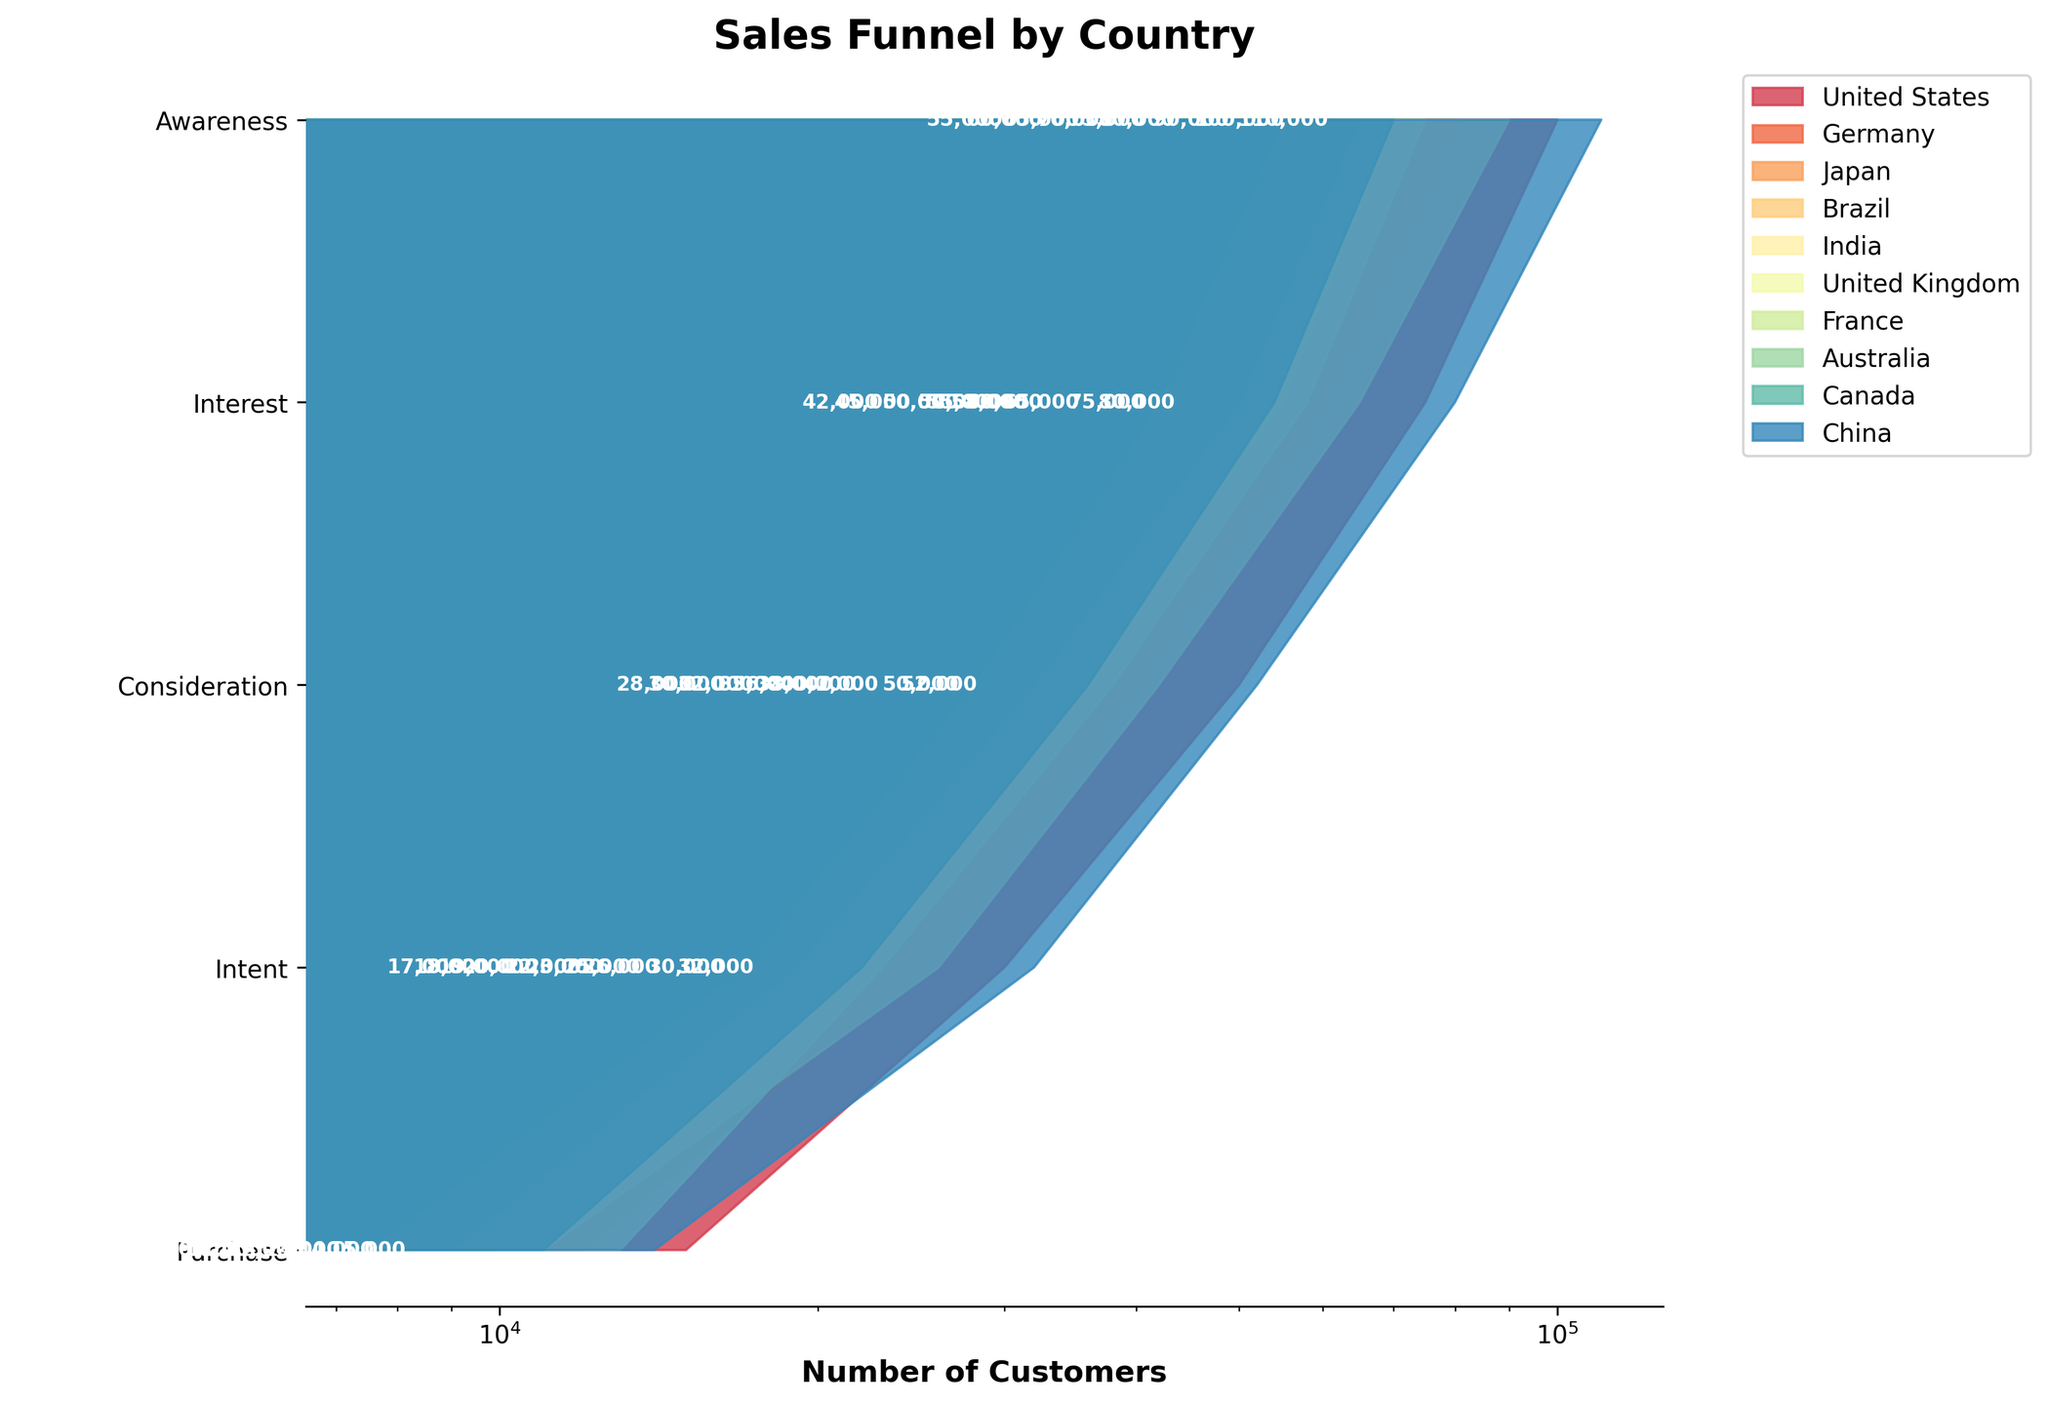What is the title of the funnel chart? The chart has a prominent title located at the top, which indicates what the plot is about. By reading this, we can identify that the title is related to sales conversion rates by country.
Answer: Sales Funnel by Country Which country has the highest number of customers in the 'Interest' stage? Upon examining the data in the visual representation, we can see that each funnel segment is labeled with the number of customers in the respective stage. We need to identify the highest among the 'Interest' stage labels.
Answer: China What's the difference in the number of customers at the 'Intent' stage between the United States and China? From the labels, we find the number of customers at the 'Intent' stage for both countries. For the United States, it's 30,000, and for China, it's 32,000. The difference is calculated as 32,000 - 30,000.
Answer: 2,000 How does the 'Purchase' stage customer count compare between Brazil and France? By examining the labels on the 'Purchase' stage of the funnel for Brazil and France, we spot that Brazil has 8,000 and France has 9,000. Since 9,000 is greater than 8,000, France has more customers in this stage.
Answer: France has more customers Which country's funnel shows the greatest drop from 'Awareness' to 'Interest'? To determine this, we should calculate the drop for each country as 'Awareness' - 'Interest' and find which is the greatest. For the United States: 100,000 - 75,000 = 25,000, Germany: 80,000 - 60,000 = 20,000, and so on. China, with a drop of 110,000 - 80,000 = 30,000, has the greatest drop.
Answer: China Which country has the most distinctively colored segment for 'Consideration' in the funnel chart? Each country's segments in the funnel chart use distinct colors. By noting the colors used and looking specifically at the 'Consideration' stage, we can identify the one with the most unique or easily distinguishable color. According to the chart, this appears to be Germany as it utilizes a very noticeable segment color.
Answer: Germany Did all countries have fewer than 60,000 customers in the 'Interest' stage? We go through each label for the 'Interest' stage to confirm: United States has 75,000, Germany 60,000, Japan 55,000, and so forth. Not all have fewer than 60,000, particularly the United States.
Answer: No What is the sum of customers at the 'Purchase' stage across the United States, Japan, and Australia? Summing the 'Purchase' stage customers of these three countries: United States = 15,000, Japan = 10,000, and Australia = 7,500. Thus, 15,000 + 10,000 + 7,500.
Answer: 32,500 